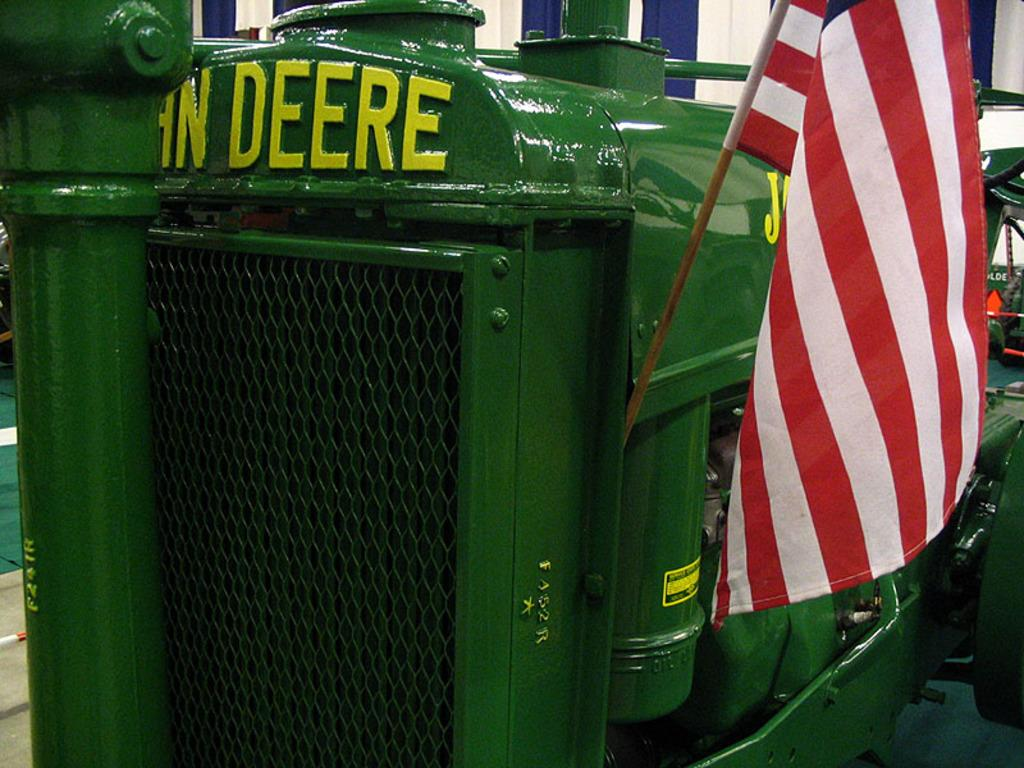What type of object is present in the image? There is a vehicle in the image. What is the color of the vehicle? The vehicle is green in color. Is there any additional feature on the vehicle? Yes, there is a flag fixed to the vehicle. Where might this image have been taken? The image appears to be taken in a hall. What colors can be seen in the background of the image? There is a cloth with blue and white colors in the background. What type of glue is being used by the stranger in the image? There is no stranger or glue present in the image. What type of school is depicted in the image? The image does not depict a school; it features a vehicle in a hall with a flag and a blue and white cloth in the background. 